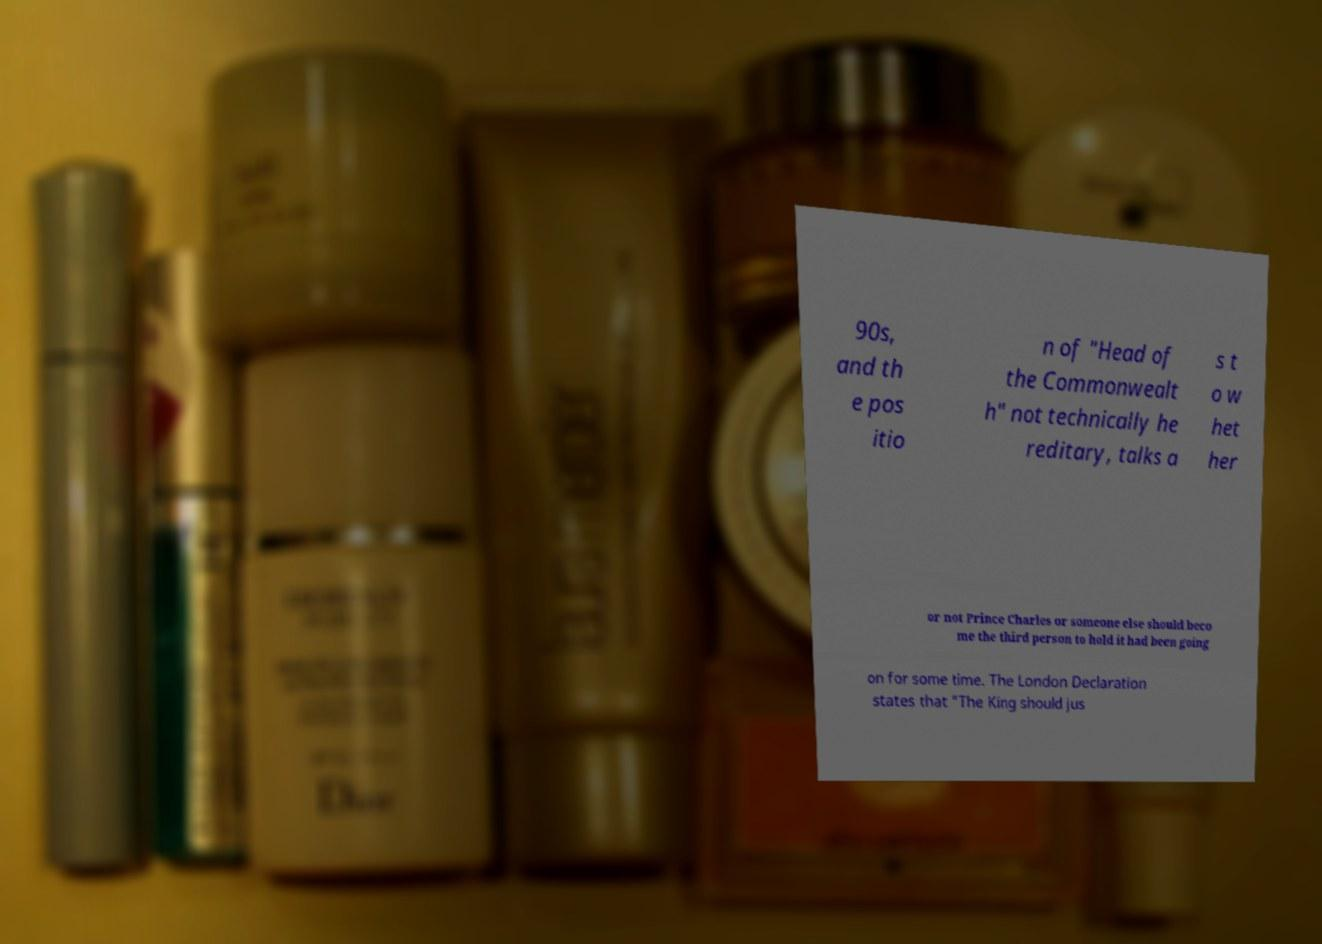Could you assist in decoding the text presented in this image and type it out clearly? 90s, and th e pos itio n of "Head of the Commonwealt h" not technically he reditary, talks a s t o w het her or not Prince Charles or someone else should beco me the third person to hold it had been going on for some time. The London Declaration states that "The King should jus 